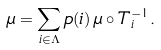<formula> <loc_0><loc_0><loc_500><loc_500>\mu = \sum _ { i \in \Lambda } p ( i ) \, \mu \circ T _ { i } ^ { - 1 } .</formula> 